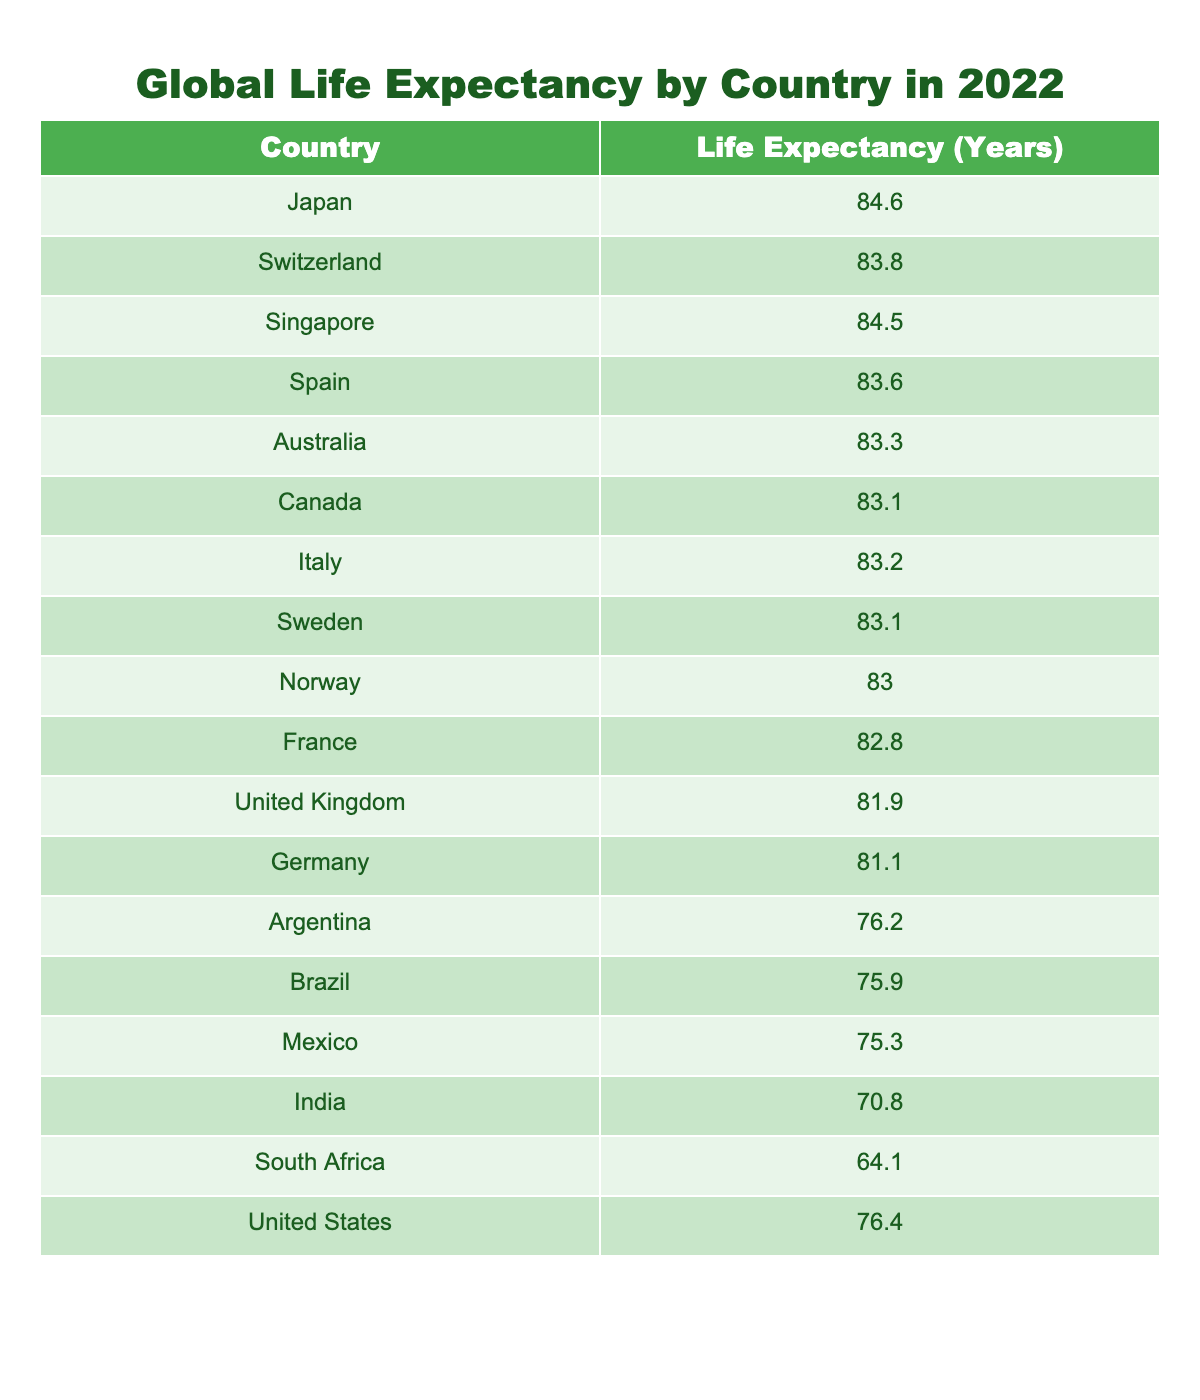What is the life expectancy in Japan? The table lists Japan's life expectancy as 84.6 years. This value is found directly in the corresponding row under the 'Life Expectancy (Years)' column.
Answer: 84.6 Which country has the lowest life expectancy from the table? The table indicates South Africa has the lowest life expectancy at 64.1 years, which is the smallest value in the 'Life Expectancy (Years)' column.
Answer: South Africa What is the difference in life expectancy between the United States and Brazil? The life expectancy in the United States is 76.4 years and in Brazil, it is 75.9 years. The difference is calculated as 76.4 - 75.9 = 0.5 years.
Answer: 0.5 Do more than half of the countries listed have a life expectancy over 80 years? There are 8 countries with life expectancies over 80 years: Japan, Switzerland, Singapore, Spain, Australia, Canada, Italy, and Sweden. Out of 15 countries total, 8 is more than half. Therefore, the statement is true.
Answer: Yes What is the average life expectancy of the countries in the table? To find the average, we sum all life expectancy values: 84.6 + 83.8 + 84.5 + 83.6 + 83.3 + 83.1 + 83.2 + 83.1 + 83.0 + 82.8 + 81.9 + 81.1 + 76.2 + 75.9 + 75.3 + 70.8 + 64.1 + 76.4 = 1280.2. There are 17 countries, so the average is 1280.2 ÷ 17 ≈ 75.4 years.
Answer: 75.4 Is Germany's life expectancy greater than Argentina's? Germany's life expectancy is 81.1 years, while Argentina's is 76.2 years. Since 81.1 is greater than 76.2, the statement is true.
Answer: Yes List the countries with life expectancy between 75 and 80 years. From the table, the countries that fall within this range are United States (76.4), Argentina (76.2), Brazil (75.9), and Mexico (75.3). By checking each listed country against the specified range, these four meet the criteria.
Answer: United States, Argentina, Brazil, Mexico What is the median life expectancy of the countries in the table? To find the median, we first need to list the life expectancies in ascending order: 64.1, 70.8, 75.3, 75.9, 76.2, 76.4, 81.1, 81.9, 82.8, 83.0, 83.1, 83.1, 83.2, 83.3, 83.6, 84.5, 84.6. There are 17 values, and the median is the 9th value, which is 82.8 years.
Answer: 82.8 How many countries have a life expectancy greater than 82 years? The countries with a life expectancy greater than 82 years are Japan (84.6), Singapore (84.5), Switzerland (83.8), Spain (83.6), Australia (83.3), Canada (83.1), Italy (83.2), Sweden (83.1), Norway (83.0), and France (82.8). This makes a total of 10 countries.
Answer: 10 